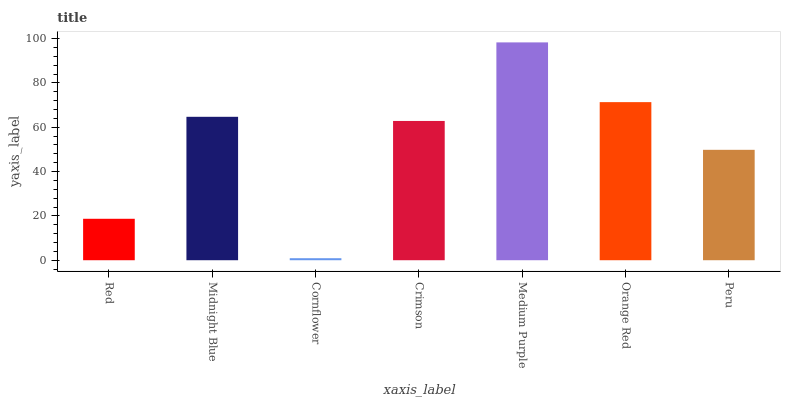Is Cornflower the minimum?
Answer yes or no. Yes. Is Medium Purple the maximum?
Answer yes or no. Yes. Is Midnight Blue the minimum?
Answer yes or no. No. Is Midnight Blue the maximum?
Answer yes or no. No. Is Midnight Blue greater than Red?
Answer yes or no. Yes. Is Red less than Midnight Blue?
Answer yes or no. Yes. Is Red greater than Midnight Blue?
Answer yes or no. No. Is Midnight Blue less than Red?
Answer yes or no. No. Is Crimson the high median?
Answer yes or no. Yes. Is Crimson the low median?
Answer yes or no. Yes. Is Cornflower the high median?
Answer yes or no. No. Is Medium Purple the low median?
Answer yes or no. No. 